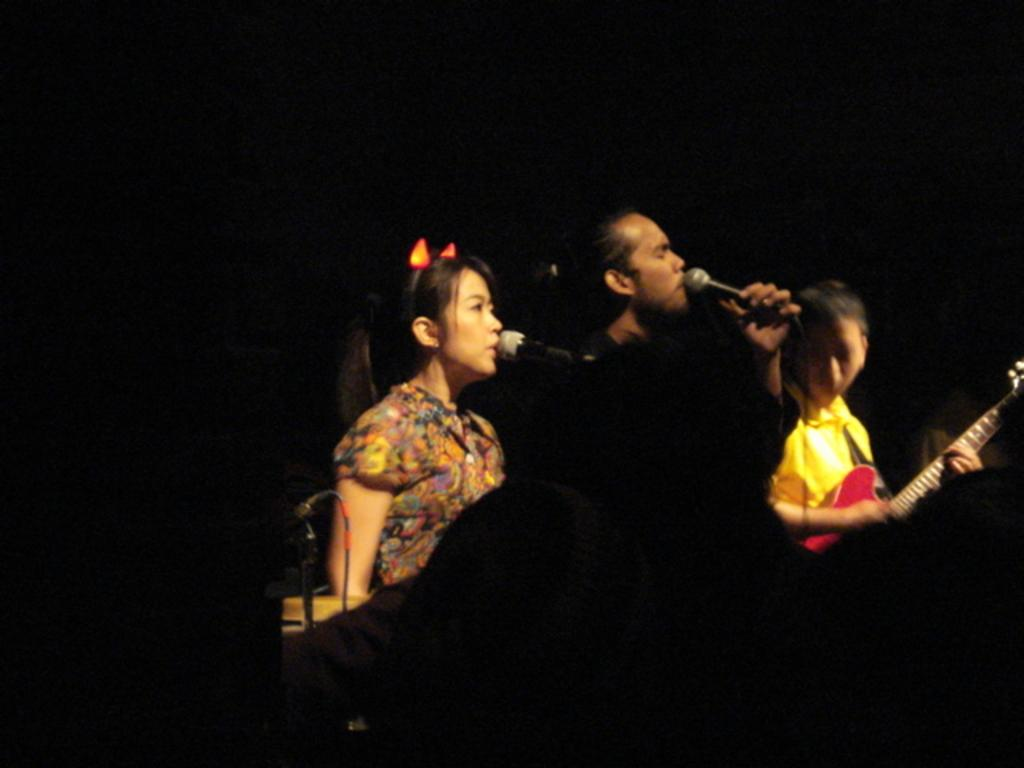Who are the people in the image? There is a woman and a man in the image. What are the woman and the man doing in the image? Both the woman and the man are singing in the image. What object is present that is commonly used for amplifying sound? There is a microphone in the image. What musical instrument can be seen being played in the image? There is a person playing a guitar in the image. What type of stick can be seen in the alley next to the sun in the image? There is no alley, sun, or stick present in the image. 